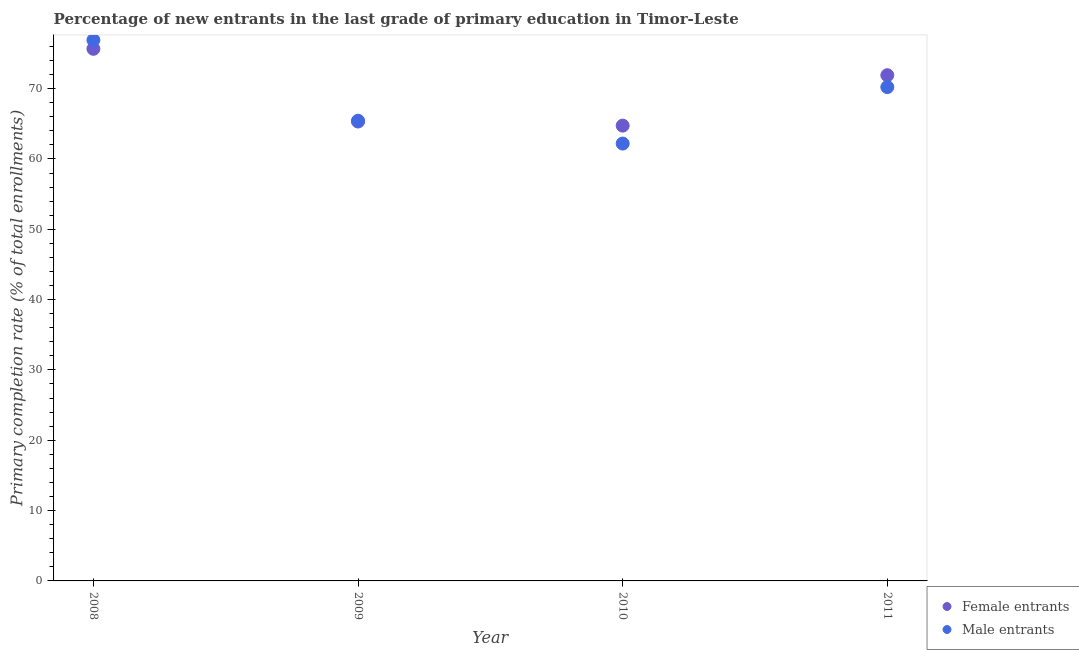How many different coloured dotlines are there?
Make the answer very short. 2. What is the primary completion rate of female entrants in 2008?
Keep it short and to the point. 75.66. Across all years, what is the maximum primary completion rate of male entrants?
Make the answer very short. 76.9. Across all years, what is the minimum primary completion rate of female entrants?
Your response must be concise. 64.74. In which year was the primary completion rate of female entrants minimum?
Your answer should be compact. 2010. What is the total primary completion rate of female entrants in the graph?
Keep it short and to the point. 277.62. What is the difference between the primary completion rate of female entrants in 2009 and that in 2010?
Keep it short and to the point. 0.58. What is the difference between the primary completion rate of female entrants in 2010 and the primary completion rate of male entrants in 2008?
Offer a very short reply. -12.17. What is the average primary completion rate of female entrants per year?
Ensure brevity in your answer.  69.4. In the year 2011, what is the difference between the primary completion rate of male entrants and primary completion rate of female entrants?
Provide a short and direct response. -1.69. In how many years, is the primary completion rate of female entrants greater than 16 %?
Provide a short and direct response. 4. What is the ratio of the primary completion rate of male entrants in 2008 to that in 2011?
Provide a succinct answer. 1.1. Is the primary completion rate of male entrants in 2009 less than that in 2011?
Offer a very short reply. Yes. What is the difference between the highest and the second highest primary completion rate of female entrants?
Your answer should be very brief. 3.75. What is the difference between the highest and the lowest primary completion rate of female entrants?
Your answer should be very brief. 10.92. Does the primary completion rate of female entrants monotonically increase over the years?
Offer a terse response. No. How many years are there in the graph?
Provide a succinct answer. 4. What is the difference between two consecutive major ticks on the Y-axis?
Make the answer very short. 10. Does the graph contain grids?
Give a very brief answer. No. Where does the legend appear in the graph?
Ensure brevity in your answer.  Bottom right. How many legend labels are there?
Give a very brief answer. 2. What is the title of the graph?
Ensure brevity in your answer.  Percentage of new entrants in the last grade of primary education in Timor-Leste. Does "Old" appear as one of the legend labels in the graph?
Your answer should be compact. No. What is the label or title of the Y-axis?
Offer a very short reply. Primary completion rate (% of total enrollments). What is the Primary completion rate (% of total enrollments) of Female entrants in 2008?
Provide a short and direct response. 75.66. What is the Primary completion rate (% of total enrollments) in Male entrants in 2008?
Provide a short and direct response. 76.9. What is the Primary completion rate (% of total enrollments) of Female entrants in 2009?
Provide a succinct answer. 65.32. What is the Primary completion rate (% of total enrollments) of Male entrants in 2009?
Ensure brevity in your answer.  65.43. What is the Primary completion rate (% of total enrollments) in Female entrants in 2010?
Keep it short and to the point. 64.74. What is the Primary completion rate (% of total enrollments) in Male entrants in 2010?
Give a very brief answer. 62.19. What is the Primary completion rate (% of total enrollments) of Female entrants in 2011?
Offer a terse response. 71.9. What is the Primary completion rate (% of total enrollments) of Male entrants in 2011?
Offer a terse response. 70.22. Across all years, what is the maximum Primary completion rate (% of total enrollments) of Female entrants?
Give a very brief answer. 75.66. Across all years, what is the maximum Primary completion rate (% of total enrollments) of Male entrants?
Give a very brief answer. 76.9. Across all years, what is the minimum Primary completion rate (% of total enrollments) of Female entrants?
Give a very brief answer. 64.74. Across all years, what is the minimum Primary completion rate (% of total enrollments) of Male entrants?
Ensure brevity in your answer.  62.19. What is the total Primary completion rate (% of total enrollments) of Female entrants in the graph?
Ensure brevity in your answer.  277.62. What is the total Primary completion rate (% of total enrollments) of Male entrants in the graph?
Make the answer very short. 274.75. What is the difference between the Primary completion rate (% of total enrollments) in Female entrants in 2008 and that in 2009?
Offer a very short reply. 10.34. What is the difference between the Primary completion rate (% of total enrollments) in Male entrants in 2008 and that in 2009?
Ensure brevity in your answer.  11.47. What is the difference between the Primary completion rate (% of total enrollments) in Female entrants in 2008 and that in 2010?
Give a very brief answer. 10.92. What is the difference between the Primary completion rate (% of total enrollments) of Male entrants in 2008 and that in 2010?
Keep it short and to the point. 14.72. What is the difference between the Primary completion rate (% of total enrollments) of Female entrants in 2008 and that in 2011?
Your answer should be compact. 3.75. What is the difference between the Primary completion rate (% of total enrollments) in Male entrants in 2008 and that in 2011?
Offer a very short reply. 6.69. What is the difference between the Primary completion rate (% of total enrollments) in Female entrants in 2009 and that in 2010?
Offer a terse response. 0.58. What is the difference between the Primary completion rate (% of total enrollments) in Male entrants in 2009 and that in 2010?
Your answer should be compact. 3.24. What is the difference between the Primary completion rate (% of total enrollments) of Female entrants in 2009 and that in 2011?
Your answer should be compact. -6.58. What is the difference between the Primary completion rate (% of total enrollments) in Male entrants in 2009 and that in 2011?
Make the answer very short. -4.79. What is the difference between the Primary completion rate (% of total enrollments) of Female entrants in 2010 and that in 2011?
Your response must be concise. -7.17. What is the difference between the Primary completion rate (% of total enrollments) in Male entrants in 2010 and that in 2011?
Your response must be concise. -8.03. What is the difference between the Primary completion rate (% of total enrollments) in Female entrants in 2008 and the Primary completion rate (% of total enrollments) in Male entrants in 2009?
Offer a very short reply. 10.22. What is the difference between the Primary completion rate (% of total enrollments) in Female entrants in 2008 and the Primary completion rate (% of total enrollments) in Male entrants in 2010?
Your answer should be compact. 13.47. What is the difference between the Primary completion rate (% of total enrollments) in Female entrants in 2008 and the Primary completion rate (% of total enrollments) in Male entrants in 2011?
Make the answer very short. 5.44. What is the difference between the Primary completion rate (% of total enrollments) in Female entrants in 2009 and the Primary completion rate (% of total enrollments) in Male entrants in 2010?
Provide a succinct answer. 3.13. What is the difference between the Primary completion rate (% of total enrollments) of Female entrants in 2009 and the Primary completion rate (% of total enrollments) of Male entrants in 2011?
Provide a short and direct response. -4.9. What is the difference between the Primary completion rate (% of total enrollments) of Female entrants in 2010 and the Primary completion rate (% of total enrollments) of Male entrants in 2011?
Ensure brevity in your answer.  -5.48. What is the average Primary completion rate (% of total enrollments) of Female entrants per year?
Your answer should be very brief. 69.4. What is the average Primary completion rate (% of total enrollments) of Male entrants per year?
Provide a short and direct response. 68.69. In the year 2008, what is the difference between the Primary completion rate (% of total enrollments) in Female entrants and Primary completion rate (% of total enrollments) in Male entrants?
Give a very brief answer. -1.25. In the year 2009, what is the difference between the Primary completion rate (% of total enrollments) of Female entrants and Primary completion rate (% of total enrollments) of Male entrants?
Your answer should be compact. -0.11. In the year 2010, what is the difference between the Primary completion rate (% of total enrollments) in Female entrants and Primary completion rate (% of total enrollments) in Male entrants?
Provide a succinct answer. 2.55. In the year 2011, what is the difference between the Primary completion rate (% of total enrollments) in Female entrants and Primary completion rate (% of total enrollments) in Male entrants?
Keep it short and to the point. 1.69. What is the ratio of the Primary completion rate (% of total enrollments) of Female entrants in 2008 to that in 2009?
Offer a very short reply. 1.16. What is the ratio of the Primary completion rate (% of total enrollments) in Male entrants in 2008 to that in 2009?
Keep it short and to the point. 1.18. What is the ratio of the Primary completion rate (% of total enrollments) of Female entrants in 2008 to that in 2010?
Keep it short and to the point. 1.17. What is the ratio of the Primary completion rate (% of total enrollments) in Male entrants in 2008 to that in 2010?
Offer a very short reply. 1.24. What is the ratio of the Primary completion rate (% of total enrollments) of Female entrants in 2008 to that in 2011?
Make the answer very short. 1.05. What is the ratio of the Primary completion rate (% of total enrollments) in Male entrants in 2008 to that in 2011?
Give a very brief answer. 1.1. What is the ratio of the Primary completion rate (% of total enrollments) in Male entrants in 2009 to that in 2010?
Your answer should be compact. 1.05. What is the ratio of the Primary completion rate (% of total enrollments) in Female entrants in 2009 to that in 2011?
Provide a short and direct response. 0.91. What is the ratio of the Primary completion rate (% of total enrollments) in Male entrants in 2009 to that in 2011?
Your answer should be very brief. 0.93. What is the ratio of the Primary completion rate (% of total enrollments) of Female entrants in 2010 to that in 2011?
Your answer should be very brief. 0.9. What is the ratio of the Primary completion rate (% of total enrollments) of Male entrants in 2010 to that in 2011?
Provide a short and direct response. 0.89. What is the difference between the highest and the second highest Primary completion rate (% of total enrollments) in Female entrants?
Make the answer very short. 3.75. What is the difference between the highest and the second highest Primary completion rate (% of total enrollments) of Male entrants?
Provide a short and direct response. 6.69. What is the difference between the highest and the lowest Primary completion rate (% of total enrollments) of Female entrants?
Ensure brevity in your answer.  10.92. What is the difference between the highest and the lowest Primary completion rate (% of total enrollments) of Male entrants?
Your response must be concise. 14.72. 